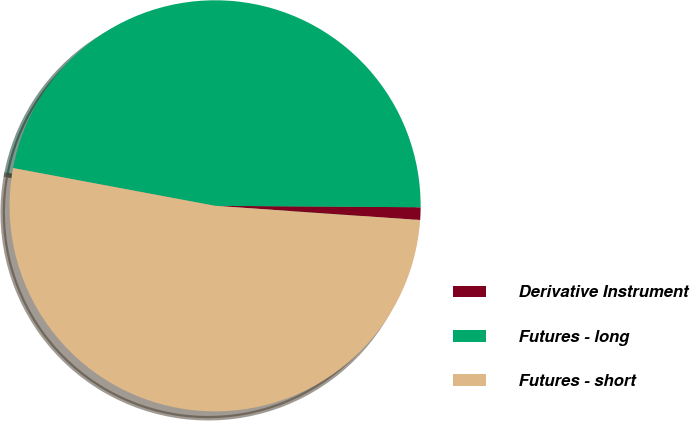Convert chart. <chart><loc_0><loc_0><loc_500><loc_500><pie_chart><fcel>Derivative Instrument<fcel>Futures - long<fcel>Futures - short<nl><fcel>0.99%<fcel>47.17%<fcel>51.84%<nl></chart> 